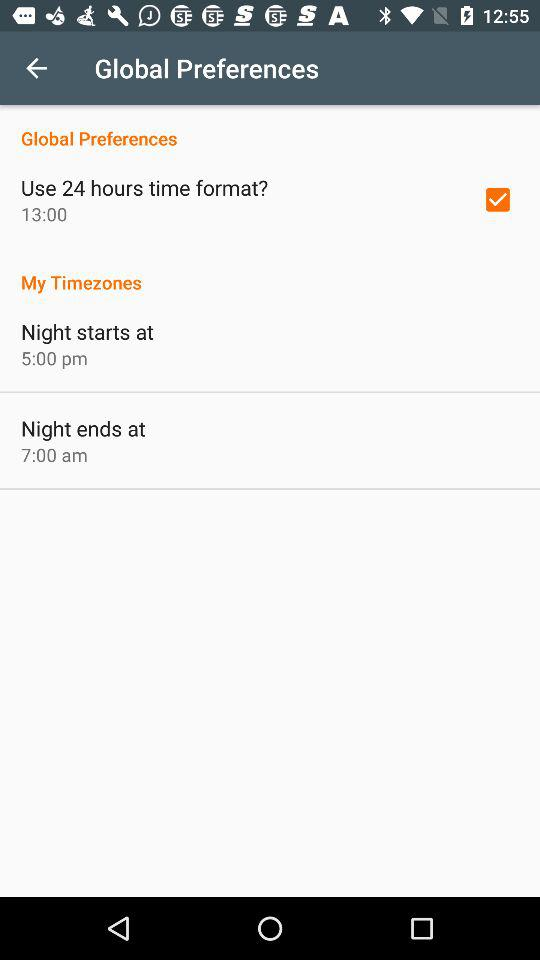At what time does the night start? The night starts at 5 p.m. 